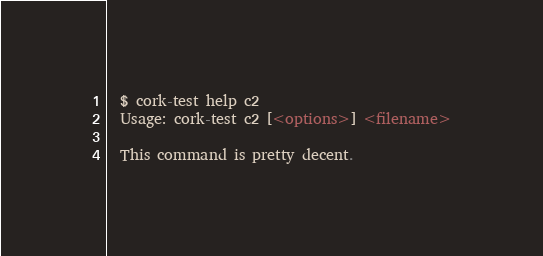<code> <loc_0><loc_0><loc_500><loc_500><_Perl_>  $ cork-test help c2
  Usage: cork-test c2 [<options>] <filename>
  
  This command is pretty decent.
</code> 